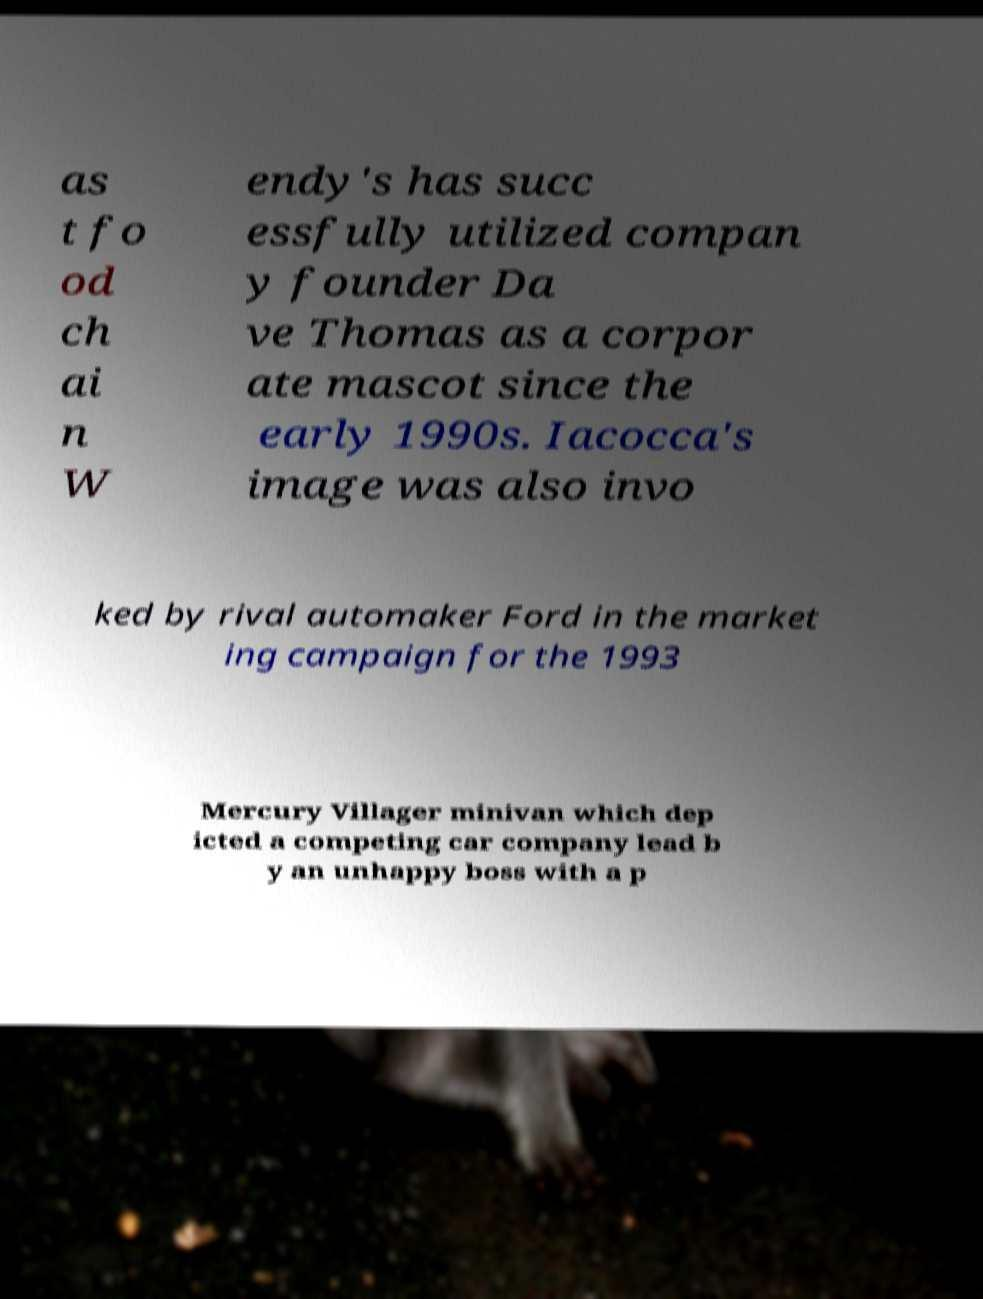I need the written content from this picture converted into text. Can you do that? as t fo od ch ai n W endy's has succ essfully utilized compan y founder Da ve Thomas as a corpor ate mascot since the early 1990s. Iacocca's image was also invo ked by rival automaker Ford in the market ing campaign for the 1993 Mercury Villager minivan which dep icted a competing car company lead b y an unhappy boss with a p 